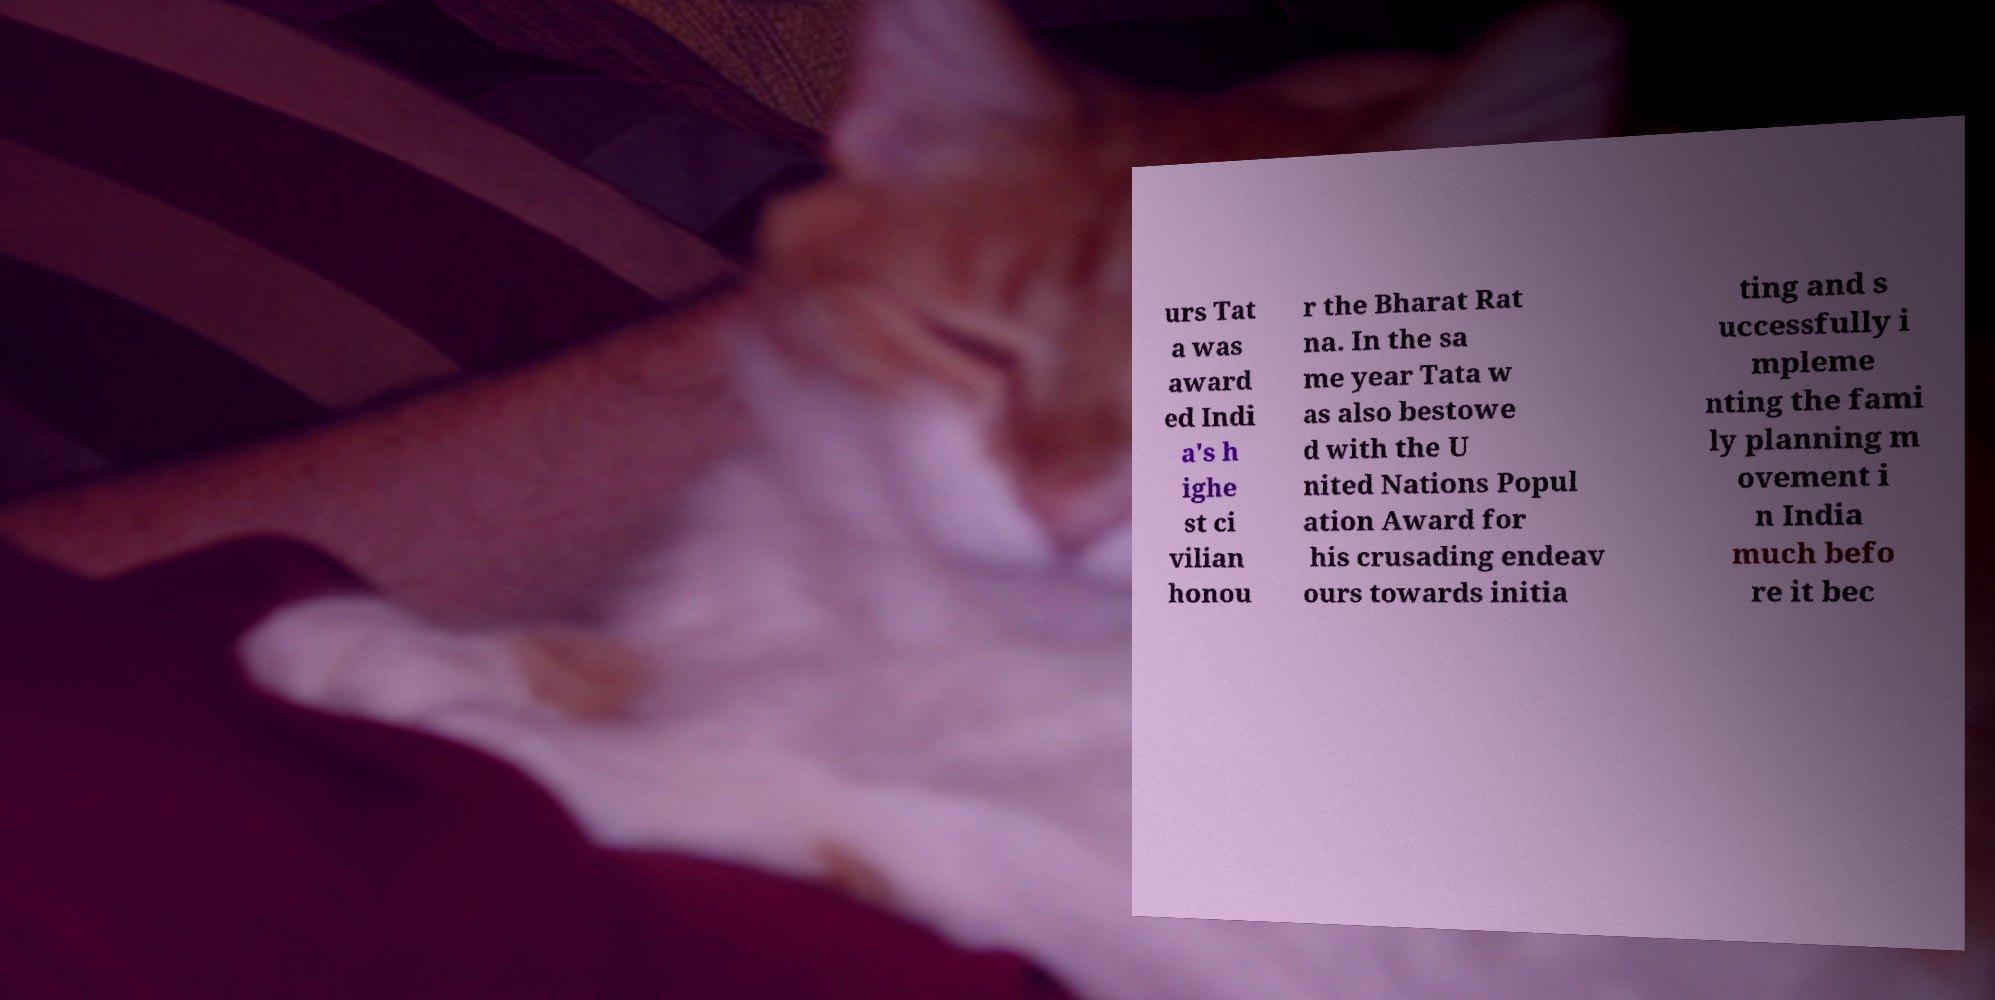What messages or text are displayed in this image? I need them in a readable, typed format. urs Tat a was award ed Indi a's h ighe st ci vilian honou r the Bharat Rat na. In the sa me year Tata w as also bestowe d with the U nited Nations Popul ation Award for his crusading endeav ours towards initia ting and s uccessfully i mpleme nting the fami ly planning m ovement i n India much befo re it bec 